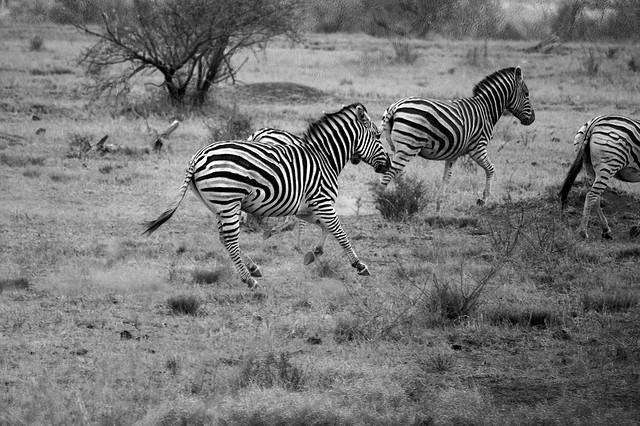Could they be in the wild?
Be succinct. Yes. Do you see anything chasing the zebras?
Quick response, please. No. Is the landscape hilly?
Write a very short answer. No. Are the animals running?
Concise answer only. Yes. Where is the picture taken?
Be succinct. Africa. 